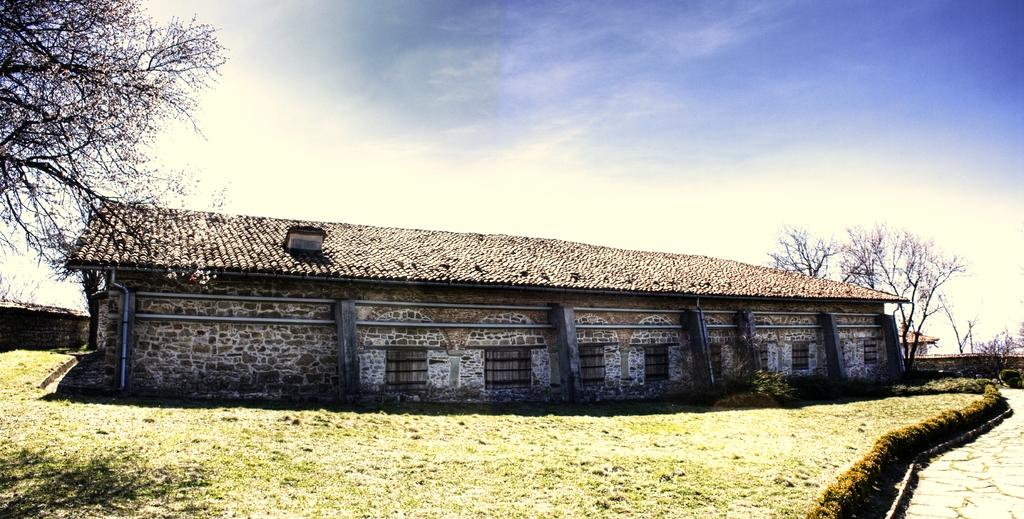What type of house is shown in the image? There is a house made of rocks in the image. What can be seen in the image besides the house? There are pipes, grass, plants, a road, trees, and other buildings visible in the image. What is the background of the image? The background of the image includes trees, other buildings, and the sky. Can you see any ghosts shopping for swimsuits in the image? There are no ghosts or swimsuits present in the image. 